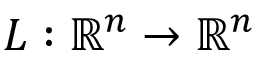Convert formula to latex. <formula><loc_0><loc_0><loc_500><loc_500>L \colon \mathbb { R } ^ { n } \to \mathbb { R } ^ { n }</formula> 